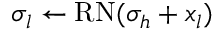<formula> <loc_0><loc_0><loc_500><loc_500>\sigma _ { l } \gets R N ( \sigma _ { h } + x _ { l } )</formula> 